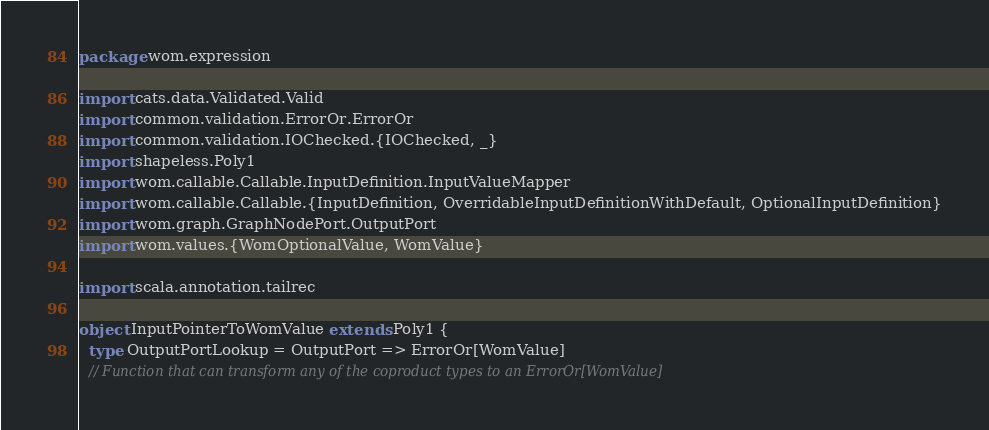<code> <loc_0><loc_0><loc_500><loc_500><_Scala_>package wom.expression

import cats.data.Validated.Valid
import common.validation.ErrorOr.ErrorOr
import common.validation.IOChecked.{IOChecked, _}
import shapeless.Poly1
import wom.callable.Callable.InputDefinition.InputValueMapper
import wom.callable.Callable.{InputDefinition, OverridableInputDefinitionWithDefault, OptionalInputDefinition}
import wom.graph.GraphNodePort.OutputPort
import wom.values.{WomOptionalValue, WomValue}

import scala.annotation.tailrec

object InputPointerToWomValue extends Poly1 {
  type OutputPortLookup = OutputPort => ErrorOr[WomValue]
  // Function that can transform any of the coproduct types to an ErrorOr[WomValue]</code> 